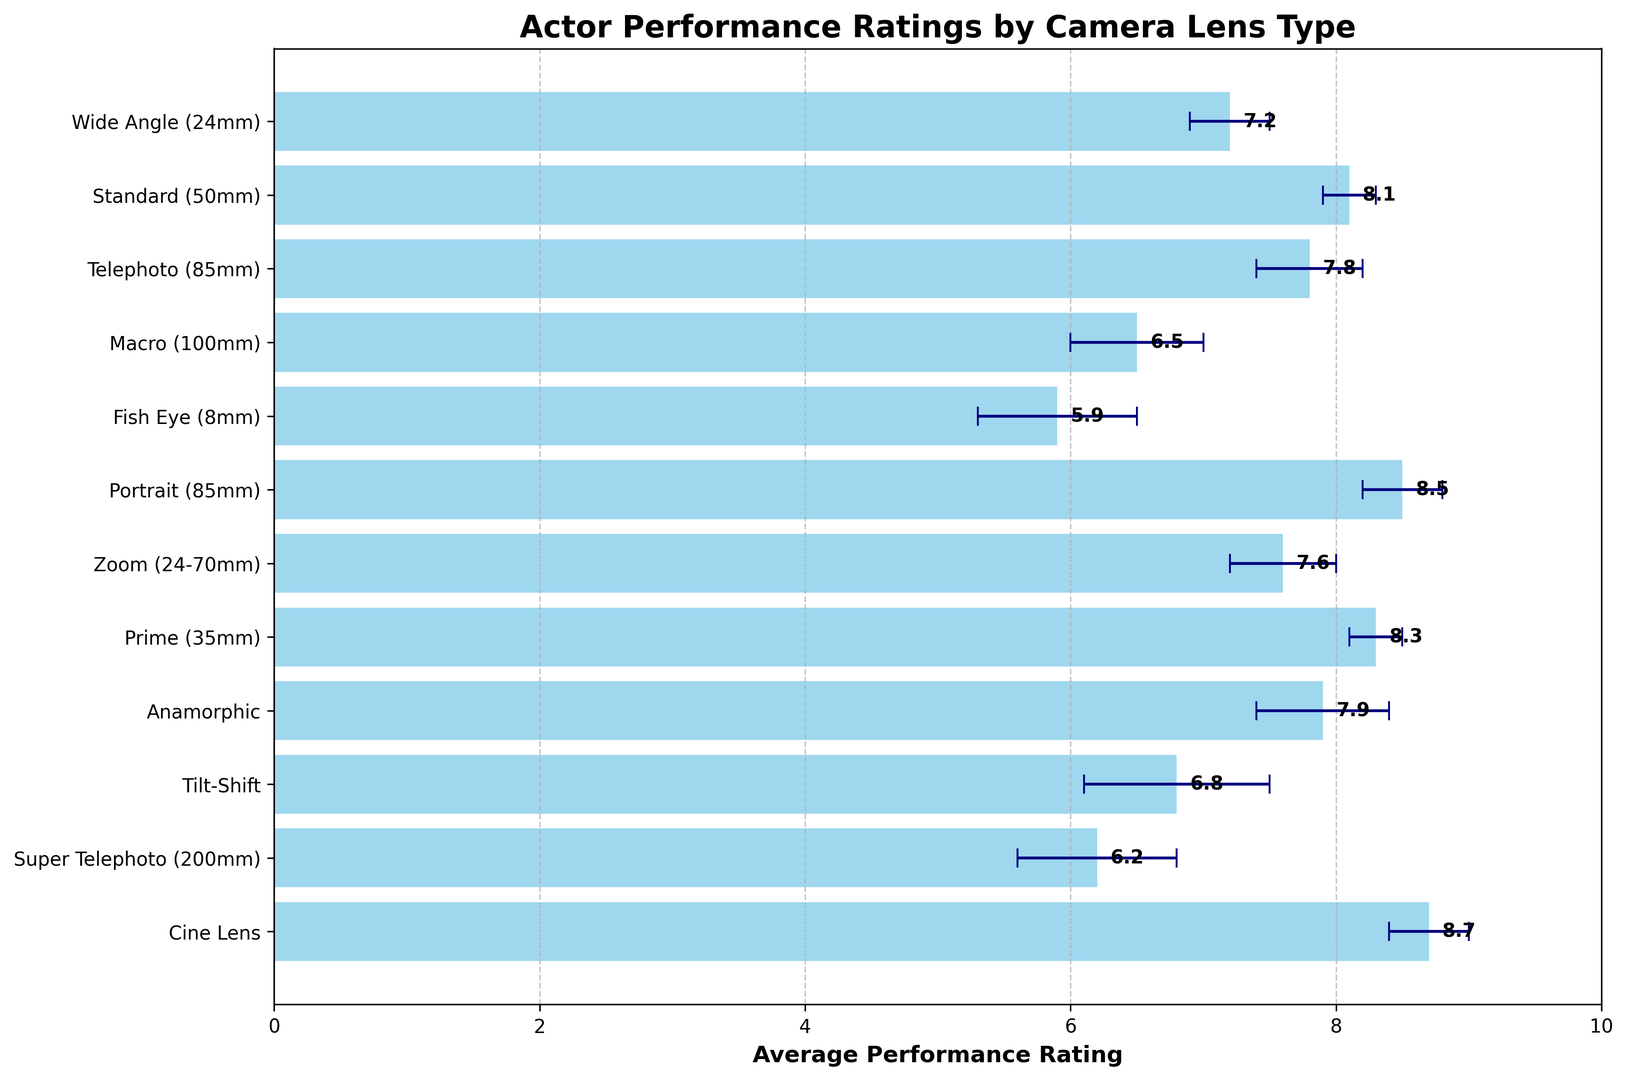Which lens type has the highest average performance rating? By looking at the highest bar in the chart, we can see which lens type corresponds to that height.
Answer: Cine Lens Which lens type has the lowest average performance rating? By identifying the shortest bar in the chart, we can determine which lens type corresponds to that height.
Answer: Fish Eye (8mm) What's the difference in average performance rating between the Portrait (85mm) and Standard (50mm) lenses? Subtract the rating of the Standard (50mm) lens (8.1) from the rating of the Portrait (85mm) lens (8.5). 8.5 - 8.1 = 0.4
Answer: 0.4 Which lens type has the largest error margin? Identify the bar with the longest error bar associated with it.
Answer: Tilt-Shift What's the average performance rating of lenses with an error margin greater than 0.5? Identify the lenses with error margins greater than 0.5: Macro (100mm) (6.5), Fish Eye (8mm) (5.9), Anamorphic (7.9), Tilt-Shift (6.8), and Super Telephoto (200mm) (6.2). Sum their ratings and divide by the number of lenses: (6.5 + 5.9 + 7.9 + 6.8 + 6.2) / 5. This equals 33.3 / 5 = 6.66.
Answer: 6.66 How many lens types have an average performance rating above 8? Count the bars with heights corresponding to ratings above 8. The lens types are Standard (50mm), Portrait (85mm), Prime (35mm), and Cine Lens. There are four lenses.
Answer: 4 Is the average rating of the Zoom (24-70mm) lens higher or lower than the median performance rating of all lens types? First, calculate the median of all performance ratings (listed in order: 5.9, 6.2, 6.5, 6.8, 7.2, 7.6, 7.8, 7.9, 8.1, 8.3, 8.5, 8.7). The median rating is the average of the 6th and 7th values: (7.6 + 7.8) / 2 = 7.7. The Zoom (24-70mm) lens has a rating of 7.6. Thus, the Zoom (24-70mm) rating is lower.
Answer: Lower What's the combined average performance rating of the Wide Angle (24mm) and Anamorphic lenses? Sum their ratings: 7.2 + 7.9 = 15.1, then divide by 2. 15.1 / 2 = 7.55.
Answer: 7.55 Which lens type has a performance rating closest to the overall average rating of all lens types? Calculate the overall average rating by summing all ratings and dividing by the number of lens types: (7.2 + 8.1 + 7.8 + 6.5 + 5.9 + 8.5 + 7.6 + 8.3 + 7.9 + 6.8 + 6.2 + 8.7) / 12. This equals 89.5 / 12 = 7.4583. The Wide Angle (24mm) lens has a rating of 7.2, closest to 7.4583.
Answer: Wide Angle (24mm) 